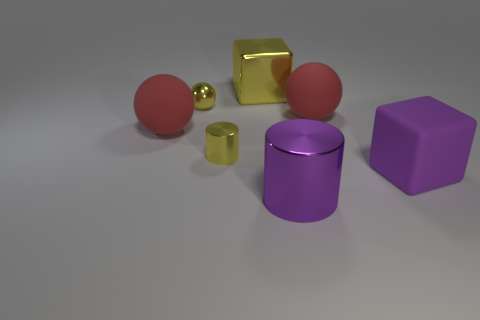Add 2 red matte things. How many objects exist? 9 Subtract all blocks. How many objects are left? 5 Add 5 big yellow objects. How many big yellow objects are left? 6 Add 3 large gray metal cubes. How many large gray metal cubes exist? 3 Subtract 1 yellow cylinders. How many objects are left? 6 Subtract all yellow metallic spheres. Subtract all large cylinders. How many objects are left? 5 